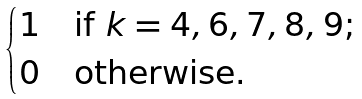Convert formula to latex. <formula><loc_0><loc_0><loc_500><loc_500>\begin{cases} 1 & \text {if $k = 4,6,7,8,9$;} \\ 0 & \text {otherwise.} \end{cases}</formula> 